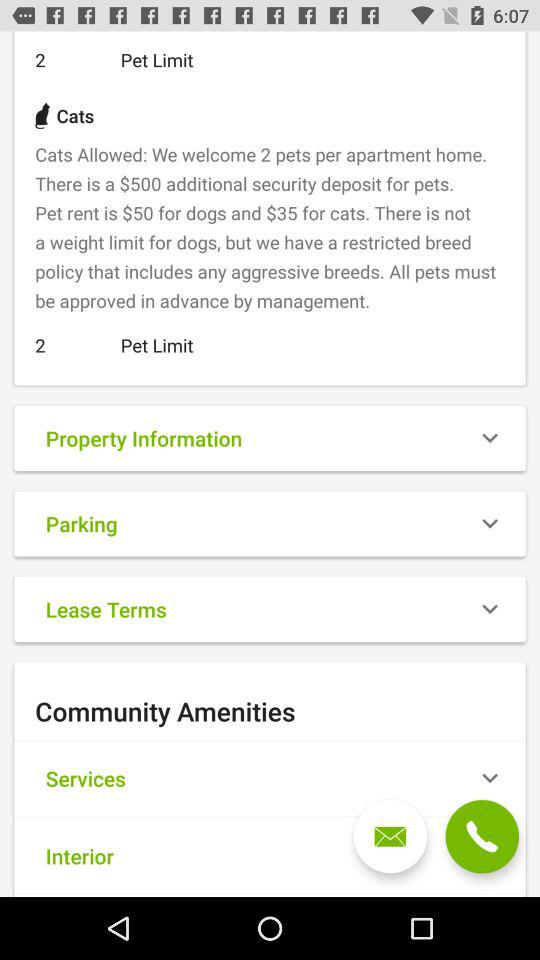What are the additional security deposits for pets? There is a $500 additional security deposit for pets. 